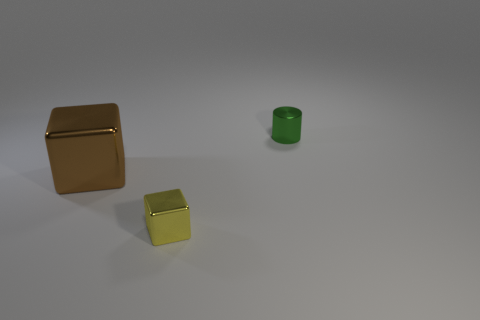Is the material of the tiny object that is behind the small yellow shiny cube the same as the small object in front of the tiny green cylinder?
Offer a very short reply. Yes. How many shiny cubes are the same size as the brown thing?
Your answer should be compact. 0. Are there fewer tiny green shiny cylinders than big cyan shiny balls?
Give a very brief answer. No. What shape is the object behind the block behind the tiny yellow metal cube?
Offer a very short reply. Cylinder. There is a green object that is the same size as the yellow block; what is its shape?
Offer a terse response. Cylinder. Is there a small green metal thing that has the same shape as the tiny yellow shiny object?
Your response must be concise. No. What is the material of the green object?
Ensure brevity in your answer.  Metal. There is a small green object; are there any cylinders to the right of it?
Make the answer very short. No. How many yellow metal things are behind the small metallic thing that is behind the brown metal object?
Offer a terse response. 0. There is a thing that is the same size as the shiny cylinder; what is it made of?
Your answer should be compact. Metal. 